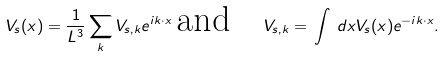Convert formula to latex. <formula><loc_0><loc_0><loc_500><loc_500>V _ { s } ( x ) = \frac { 1 } { L ^ { 3 } } \sum _ { k } V _ { s , k } e ^ { i k \cdot x } \, \text {and} \quad V _ { s , k } = \, \int \, d x V _ { s } ( x ) e ^ { - i k \cdot x } .</formula> 